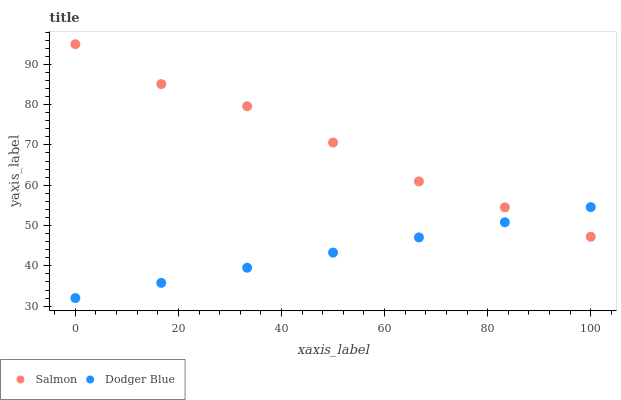Does Dodger Blue have the minimum area under the curve?
Answer yes or no. Yes. Does Salmon have the maximum area under the curve?
Answer yes or no. Yes. Does Salmon have the minimum area under the curve?
Answer yes or no. No. Is Dodger Blue the smoothest?
Answer yes or no. Yes. Is Salmon the roughest?
Answer yes or no. Yes. Is Salmon the smoothest?
Answer yes or no. No. Does Dodger Blue have the lowest value?
Answer yes or no. Yes. Does Salmon have the lowest value?
Answer yes or no. No. Does Salmon have the highest value?
Answer yes or no. Yes. Does Salmon intersect Dodger Blue?
Answer yes or no. Yes. Is Salmon less than Dodger Blue?
Answer yes or no. No. Is Salmon greater than Dodger Blue?
Answer yes or no. No. 